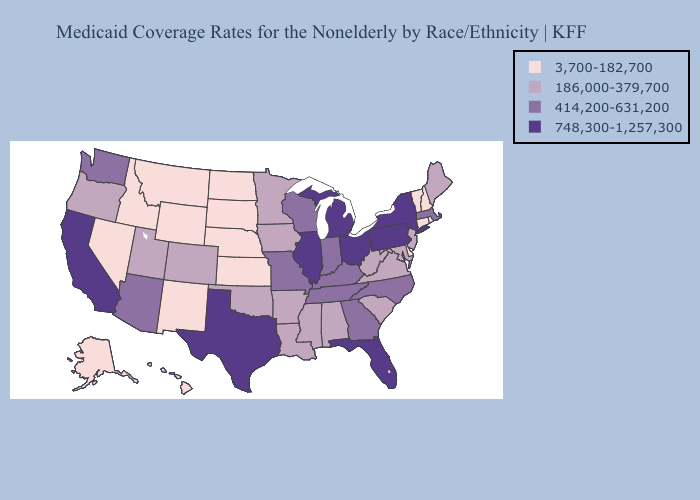Which states have the highest value in the USA?
Keep it brief. California, Florida, Illinois, Michigan, New York, Ohio, Pennsylvania, Texas. Does Oregon have a lower value than South Dakota?
Answer briefly. No. Does Colorado have the lowest value in the USA?
Write a very short answer. No. Name the states that have a value in the range 3,700-182,700?
Quick response, please. Alaska, Connecticut, Delaware, Hawaii, Idaho, Kansas, Montana, Nebraska, Nevada, New Hampshire, New Mexico, North Dakota, Rhode Island, South Dakota, Vermont, Wyoming. What is the value of Mississippi?
Quick response, please. 186,000-379,700. Among the states that border New Mexico , does Arizona have the lowest value?
Quick response, please. No. Among the states that border Connecticut , which have the highest value?
Quick response, please. New York. Among the states that border Missouri , which have the lowest value?
Write a very short answer. Kansas, Nebraska. Does Texas have the highest value in the USA?
Quick response, please. Yes. Among the states that border Connecticut , which have the highest value?
Concise answer only. New York. Does Georgia have a lower value than California?
Short answer required. Yes. What is the value of Missouri?
Write a very short answer. 414,200-631,200. Name the states that have a value in the range 3,700-182,700?
Be succinct. Alaska, Connecticut, Delaware, Hawaii, Idaho, Kansas, Montana, Nebraska, Nevada, New Hampshire, New Mexico, North Dakota, Rhode Island, South Dakota, Vermont, Wyoming. Name the states that have a value in the range 186,000-379,700?
Be succinct. Alabama, Arkansas, Colorado, Iowa, Louisiana, Maine, Maryland, Minnesota, Mississippi, New Jersey, Oklahoma, Oregon, South Carolina, Utah, Virginia, West Virginia. How many symbols are there in the legend?
Short answer required. 4. 